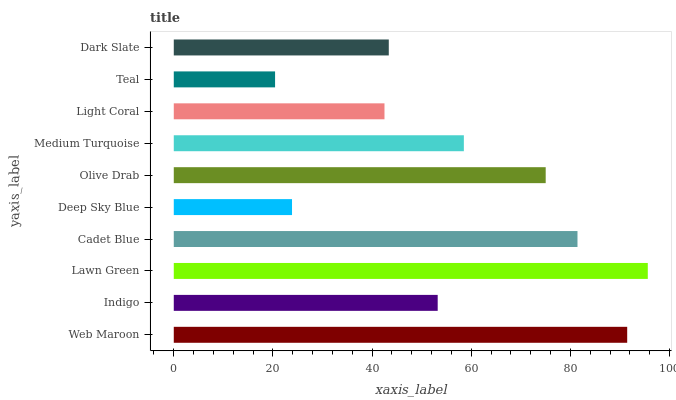Is Teal the minimum?
Answer yes or no. Yes. Is Lawn Green the maximum?
Answer yes or no. Yes. Is Indigo the minimum?
Answer yes or no. No. Is Indigo the maximum?
Answer yes or no. No. Is Web Maroon greater than Indigo?
Answer yes or no. Yes. Is Indigo less than Web Maroon?
Answer yes or no. Yes. Is Indigo greater than Web Maroon?
Answer yes or no. No. Is Web Maroon less than Indigo?
Answer yes or no. No. Is Medium Turquoise the high median?
Answer yes or no. Yes. Is Indigo the low median?
Answer yes or no. Yes. Is Web Maroon the high median?
Answer yes or no. No. Is Medium Turquoise the low median?
Answer yes or no. No. 